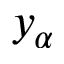<formula> <loc_0><loc_0><loc_500><loc_500>y _ { \alpha }</formula> 